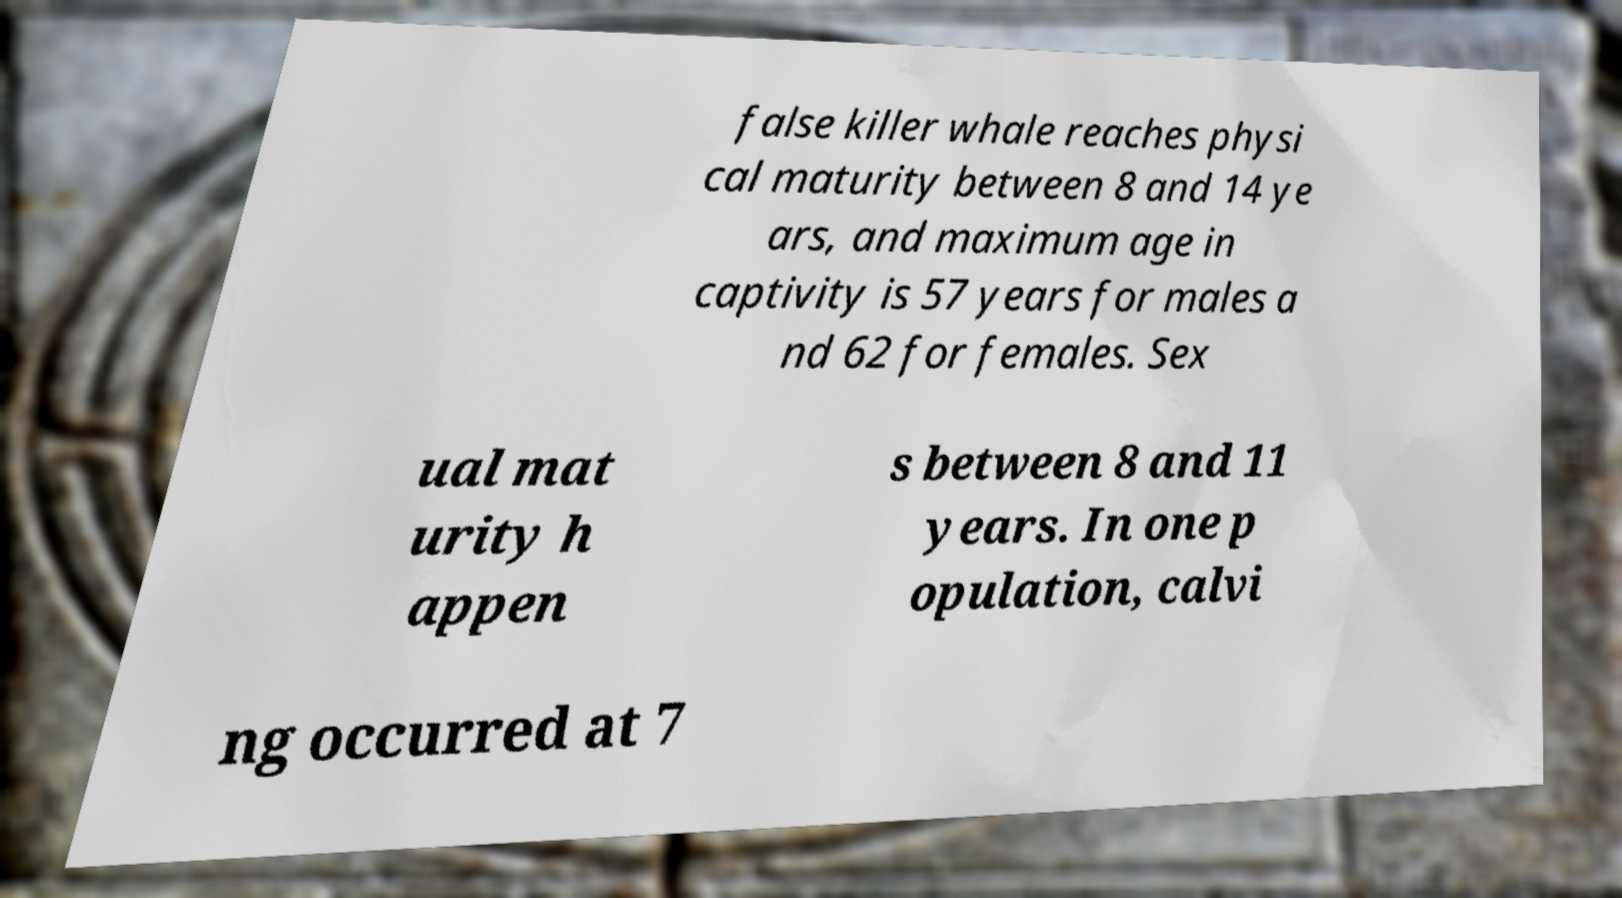Please read and relay the text visible in this image. What does it say? false killer whale reaches physi cal maturity between 8 and 14 ye ars, and maximum age in captivity is 57 years for males a nd 62 for females. Sex ual mat urity h appen s between 8 and 11 years. In one p opulation, calvi ng occurred at 7 